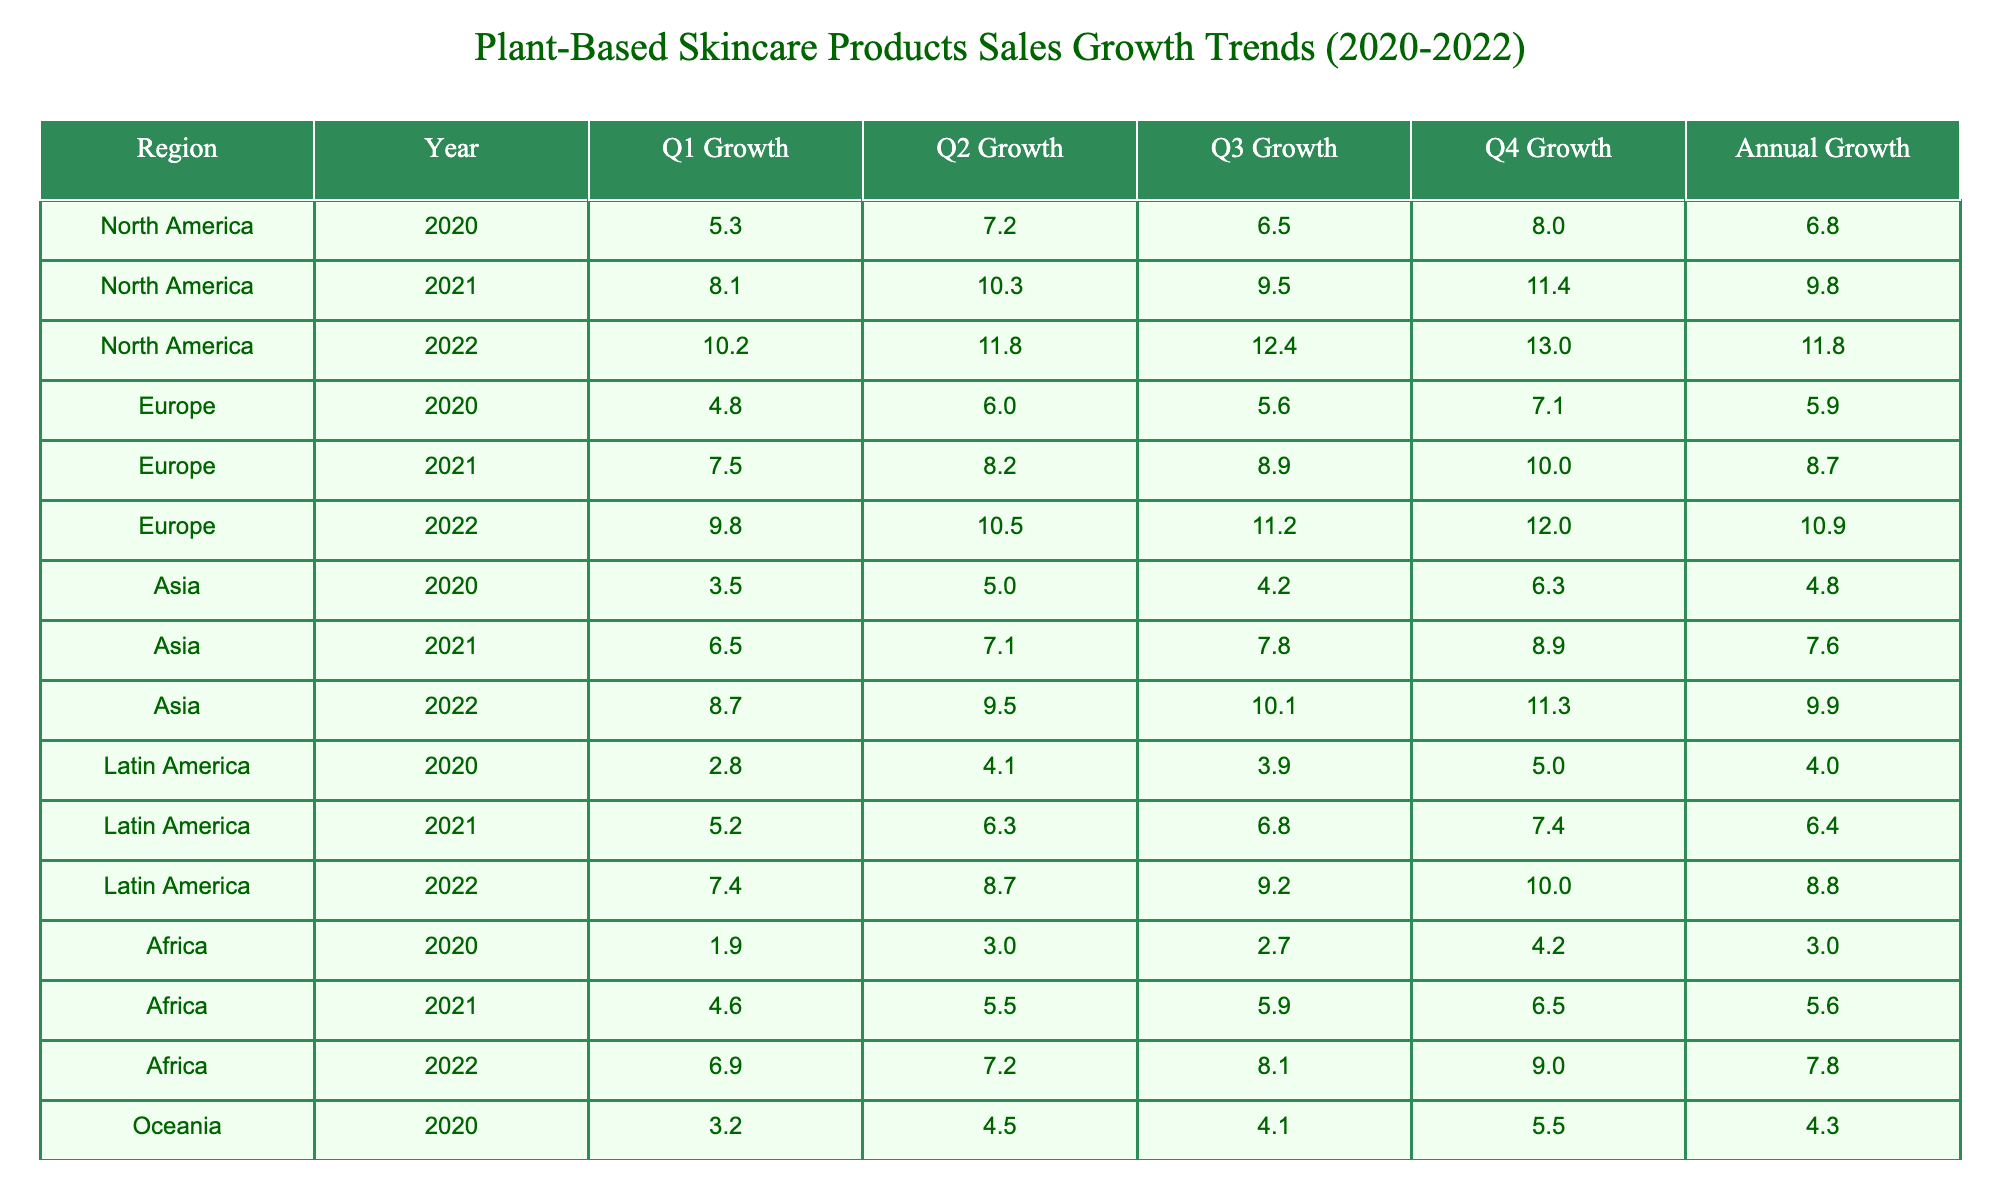What was the annual sales growth percentage for North America in 2021? The table shows that for North America, the "Annual Sales Growth (%)" under the year 2021 is listed as 9.83%.
Answer: 9.83% Which region experienced the highest annual sales growth in 2022? The annual sales growth for each region in 2022 is North America (11.85%), Europe (10.88%), Asia (9.90%), Latin America (8.83%), and Africa (7.80%). Comparing these values, North America has the highest annual sales growth.
Answer: North America What is the difference in annual sales growth between North America in 2022 and Latin America in 2021? For North America in 2022, the annual sales growth is 11.85%, and for Latin America in 2021, it is 6.43%. The difference is calculated as 11.85% - 6.43% = 5.42%.
Answer: 5.42% Did Asia show an increase in annual sales growth from 2020 to 2022? In the table, Asia's annual sales growth for 2020 is 4.75% and for 2022 it is 9.90%. Since the value increased from 4.75% to 9.90%, the answer is yes.
Answer: Yes What was the average quarterly sales growth in Q1 for all regions in 2022? The Q1 sales growth percentages for all regions in 2022 are: North America (10.2%), Europe (9.8%), Asia (8.7%), Latin America (7.4%), Africa (6.9%), and Oceania (8.1%). Adding these up gives 10.2 + 9.8 + 8.7 + 7.4 + 6.9 + 8.1 = 51.1%. Dividing this by the number of regions (6) gives an average of 51.1 / 6 = 8.52%.
Answer: 8.52% 